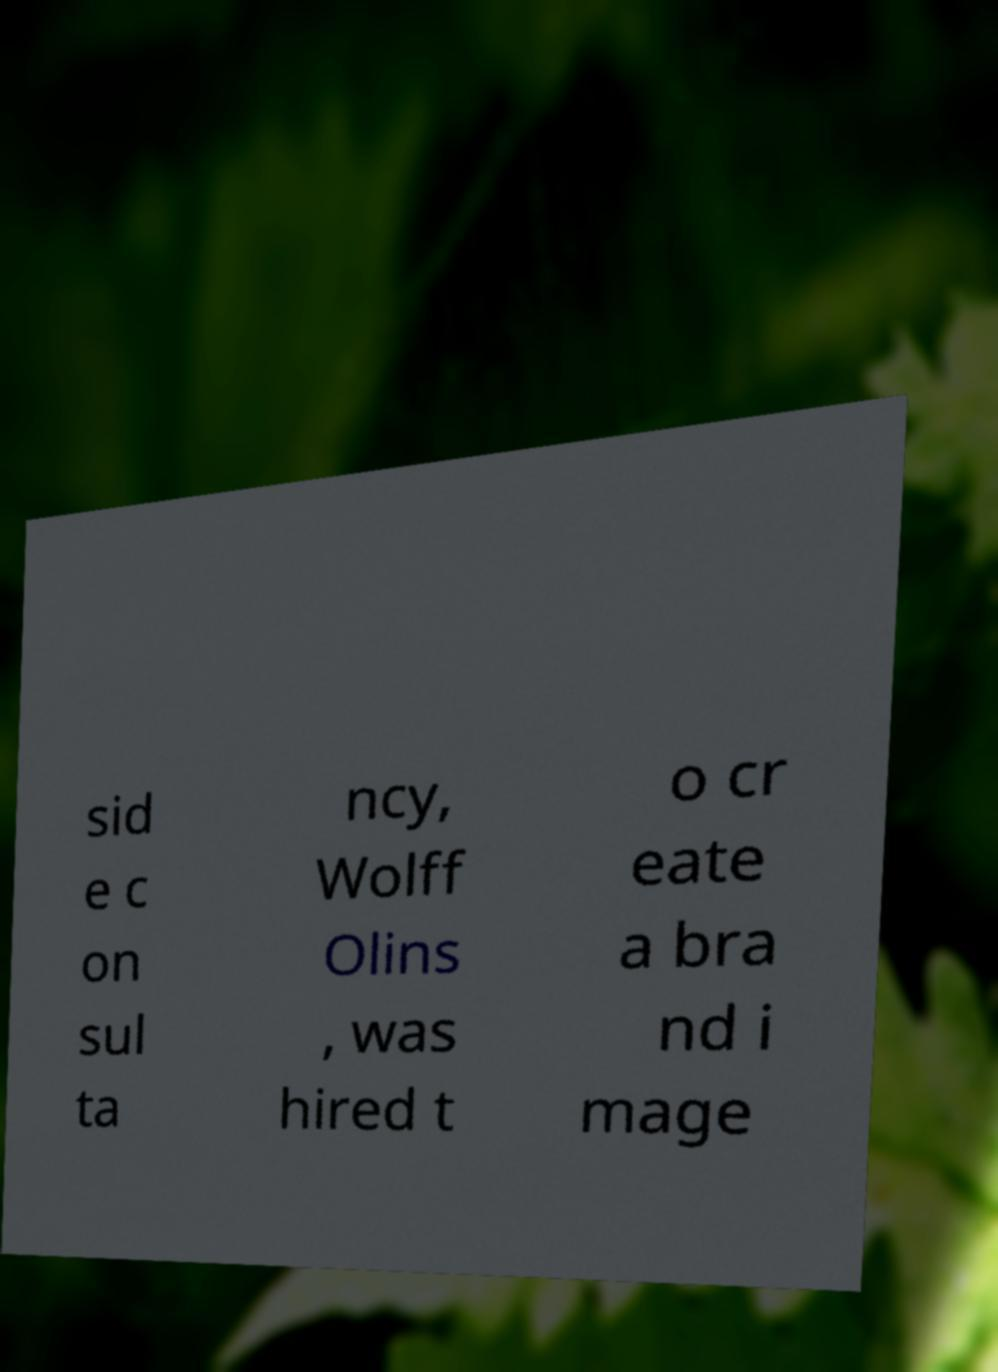Please read and relay the text visible in this image. What does it say? sid e c on sul ta ncy, Wolff Olins , was hired t o cr eate a bra nd i mage 